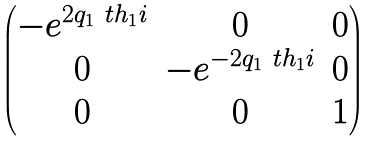<formula> <loc_0><loc_0><loc_500><loc_500>\begin{pmatrix} - e ^ { 2 q _ { 1 } \ t h _ { 1 } i } & 0 & 0 \\ 0 & - e ^ { - 2 q _ { 1 } \ t h _ { 1 } i } & 0 \\ 0 & 0 & 1 \end{pmatrix}</formula> 